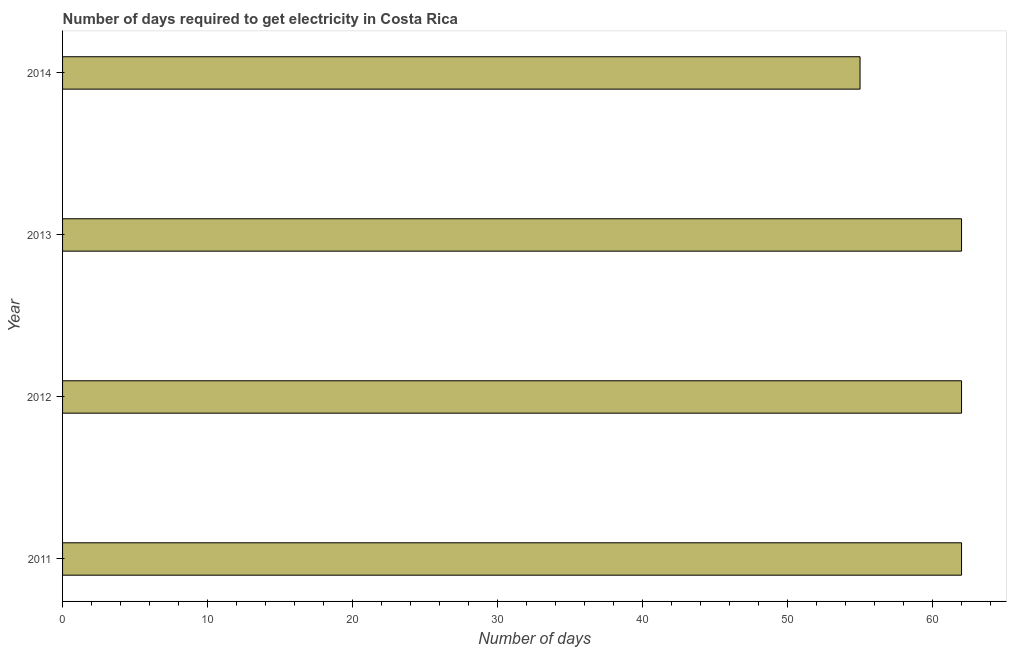Does the graph contain any zero values?
Offer a very short reply. No. What is the title of the graph?
Make the answer very short. Number of days required to get electricity in Costa Rica. What is the label or title of the X-axis?
Offer a very short reply. Number of days. Across all years, what is the maximum time to get electricity?
Offer a terse response. 62. In which year was the time to get electricity minimum?
Your response must be concise. 2014. What is the sum of the time to get electricity?
Offer a terse response. 241. What is the difference between the time to get electricity in 2011 and 2013?
Provide a short and direct response. 0. What is the average time to get electricity per year?
Provide a short and direct response. 60. Do a majority of the years between 2011 and 2012 (inclusive) have time to get electricity greater than 14 ?
Ensure brevity in your answer.  Yes. What is the ratio of the time to get electricity in 2013 to that in 2014?
Offer a terse response. 1.13. What is the difference between the highest and the second highest time to get electricity?
Your answer should be very brief. 0. Is the sum of the time to get electricity in 2011 and 2014 greater than the maximum time to get electricity across all years?
Give a very brief answer. Yes. What is the difference between the highest and the lowest time to get electricity?
Provide a short and direct response. 7. In how many years, is the time to get electricity greater than the average time to get electricity taken over all years?
Ensure brevity in your answer.  3. How many bars are there?
Your answer should be compact. 4. Are all the bars in the graph horizontal?
Your answer should be very brief. Yes. Are the values on the major ticks of X-axis written in scientific E-notation?
Keep it short and to the point. No. What is the Number of days of 2011?
Make the answer very short. 62. What is the Number of days of 2012?
Your answer should be compact. 62. What is the Number of days in 2013?
Your answer should be very brief. 62. What is the Number of days of 2014?
Your answer should be very brief. 55. What is the difference between the Number of days in 2011 and 2012?
Offer a terse response. 0. What is the difference between the Number of days in 2011 and 2013?
Give a very brief answer. 0. What is the difference between the Number of days in 2012 and 2013?
Your response must be concise. 0. What is the difference between the Number of days in 2012 and 2014?
Offer a very short reply. 7. What is the difference between the Number of days in 2013 and 2014?
Your answer should be compact. 7. What is the ratio of the Number of days in 2011 to that in 2014?
Your response must be concise. 1.13. What is the ratio of the Number of days in 2012 to that in 2014?
Your response must be concise. 1.13. What is the ratio of the Number of days in 2013 to that in 2014?
Make the answer very short. 1.13. 